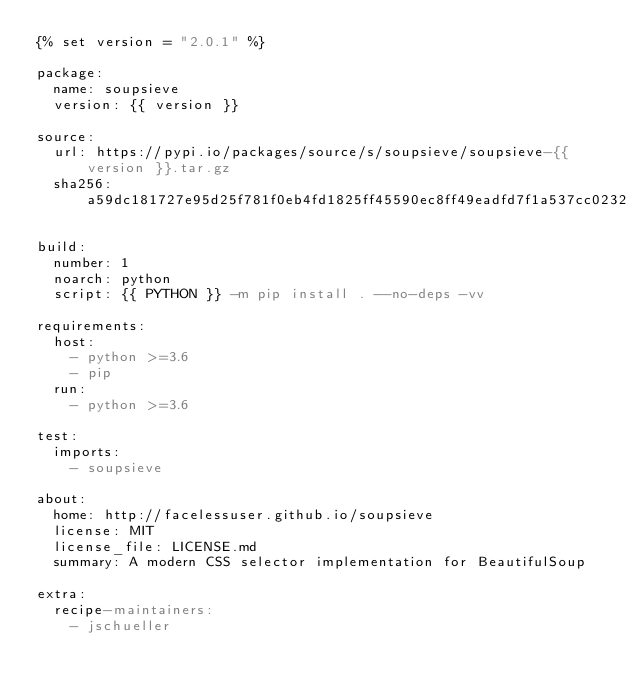Convert code to text. <code><loc_0><loc_0><loc_500><loc_500><_YAML_>{% set version = "2.0.1" %}

package:
  name: soupsieve
  version: {{ version }}

source:
  url: https://pypi.io/packages/source/s/soupsieve/soupsieve-{{ version }}.tar.gz
  sha256: a59dc181727e95d25f781f0eb4fd1825ff45590ec8ff49eadfd7f1a537cc0232

build:
  number: 1
  noarch: python
  script: {{ PYTHON }} -m pip install . --no-deps -vv

requirements:
  host:
    - python >=3.6
    - pip
  run:
    - python >=3.6

test:
  imports:
    - soupsieve

about:
  home: http://facelessuser.github.io/soupsieve
  license: MIT
  license_file: LICENSE.md
  summary: A modern CSS selector implementation for BeautifulSoup

extra:
  recipe-maintainers:
    - jschueller
</code> 